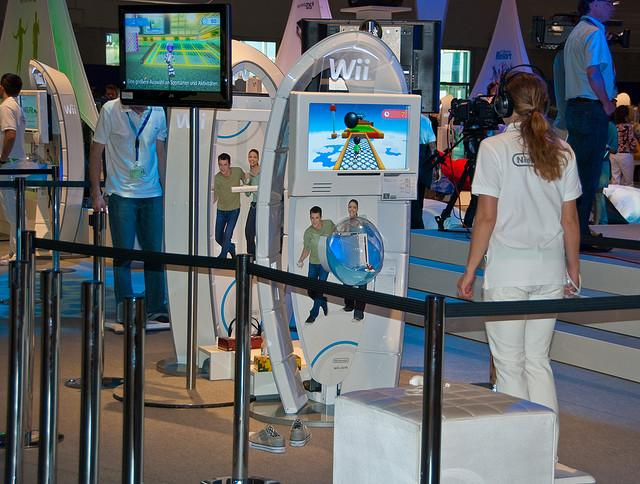What consumer electronic company made the white gaming displays? Please explain your reasoning. nintendo. Gaming displays have the wii logo on them. wii is made by nintendo. 